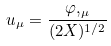Convert formula to latex. <formula><loc_0><loc_0><loc_500><loc_500>u _ { \mu } = { \frac { \varphi , _ { \mu } } { ( 2 X ) ^ { 1 / 2 } } }</formula> 